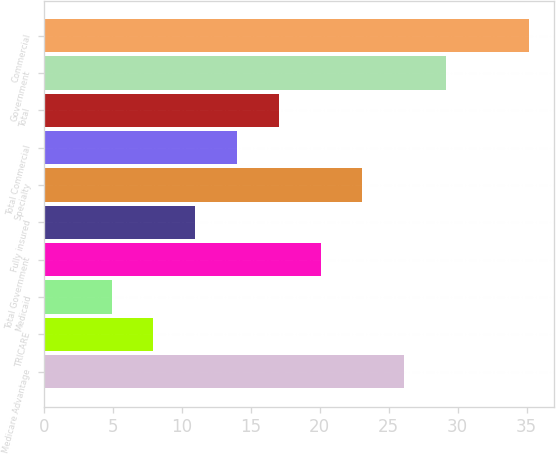Convert chart to OTSL. <chart><loc_0><loc_0><loc_500><loc_500><bar_chart><fcel>Medicare Advantage<fcel>TRICARE<fcel>Medicaid<fcel>Total Government<fcel>Fully insured<fcel>Specialty<fcel>Total Commercial<fcel>Total<fcel>Government<fcel>Commercial<nl><fcel>26.11<fcel>7.93<fcel>4.9<fcel>20.05<fcel>10.96<fcel>23.08<fcel>13.99<fcel>17.02<fcel>29.14<fcel>35.2<nl></chart> 